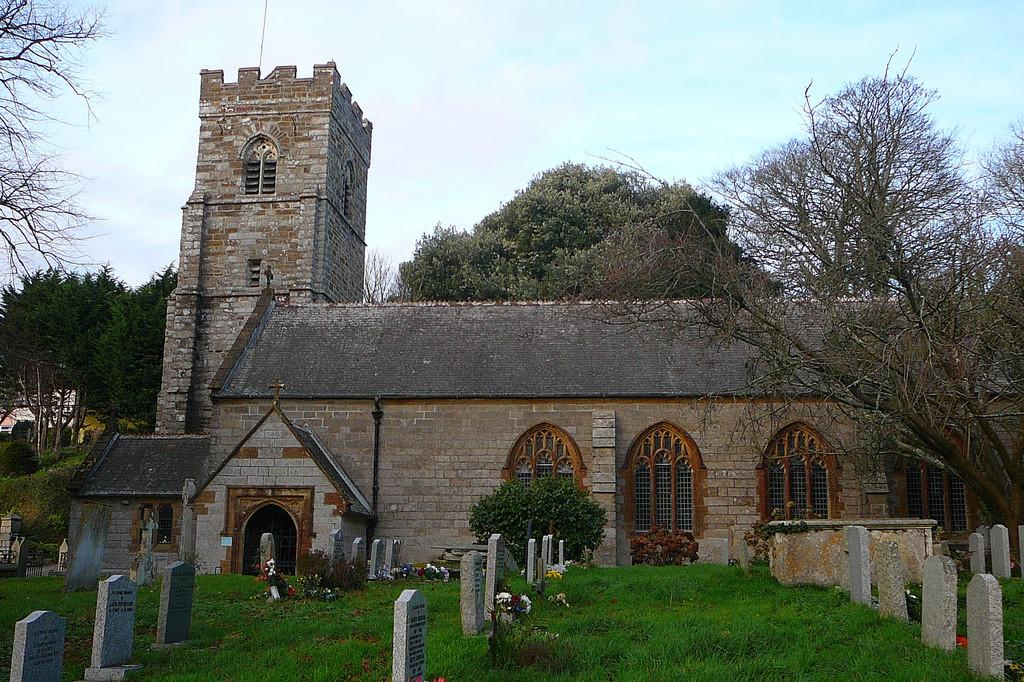What is the main structure in the center of the image? There is a fort in the center of the image. What can be found at the bottom of the image? There are graves at the bottom of the image, and grass is also present there. What is visible in the background of the image? There are trees and the sky visible in the background of the image. What type of watch can be seen on the fort in the image? There is no watch present on the fort in the image. Can you tell me how many parents are depicted in the image? There are no parents depicted in the image; it features a fort, graves, grass, trees, and the sky. 